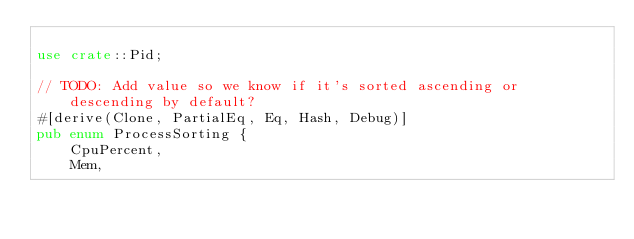<code> <loc_0><loc_0><loc_500><loc_500><_Rust_>
use crate::Pid;

// TODO: Add value so we know if it's sorted ascending or descending by default?
#[derive(Clone, PartialEq, Eq, Hash, Debug)]
pub enum ProcessSorting {
    CpuPercent,
    Mem,</code> 